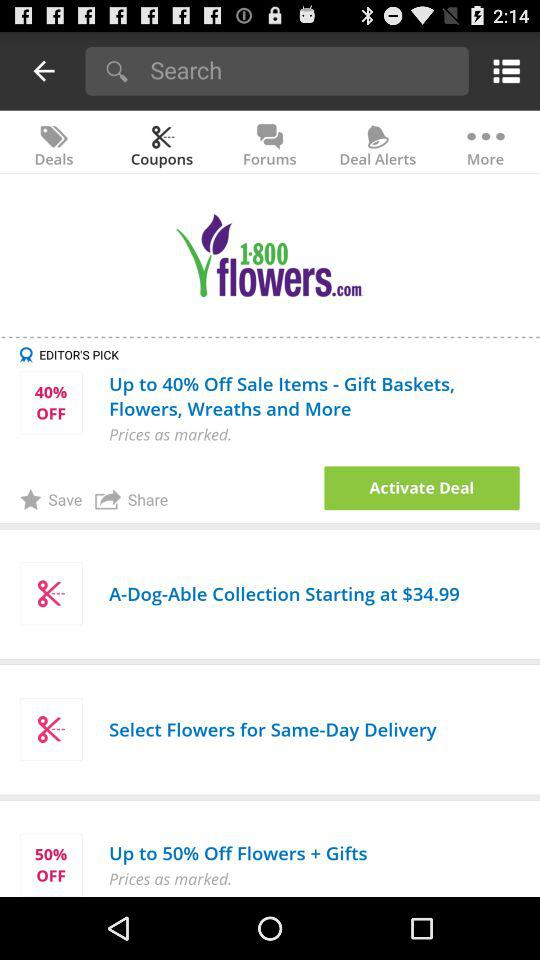Up to 50% off is available on which items? Up to 50% off is available on "Flowers + Gifts". 